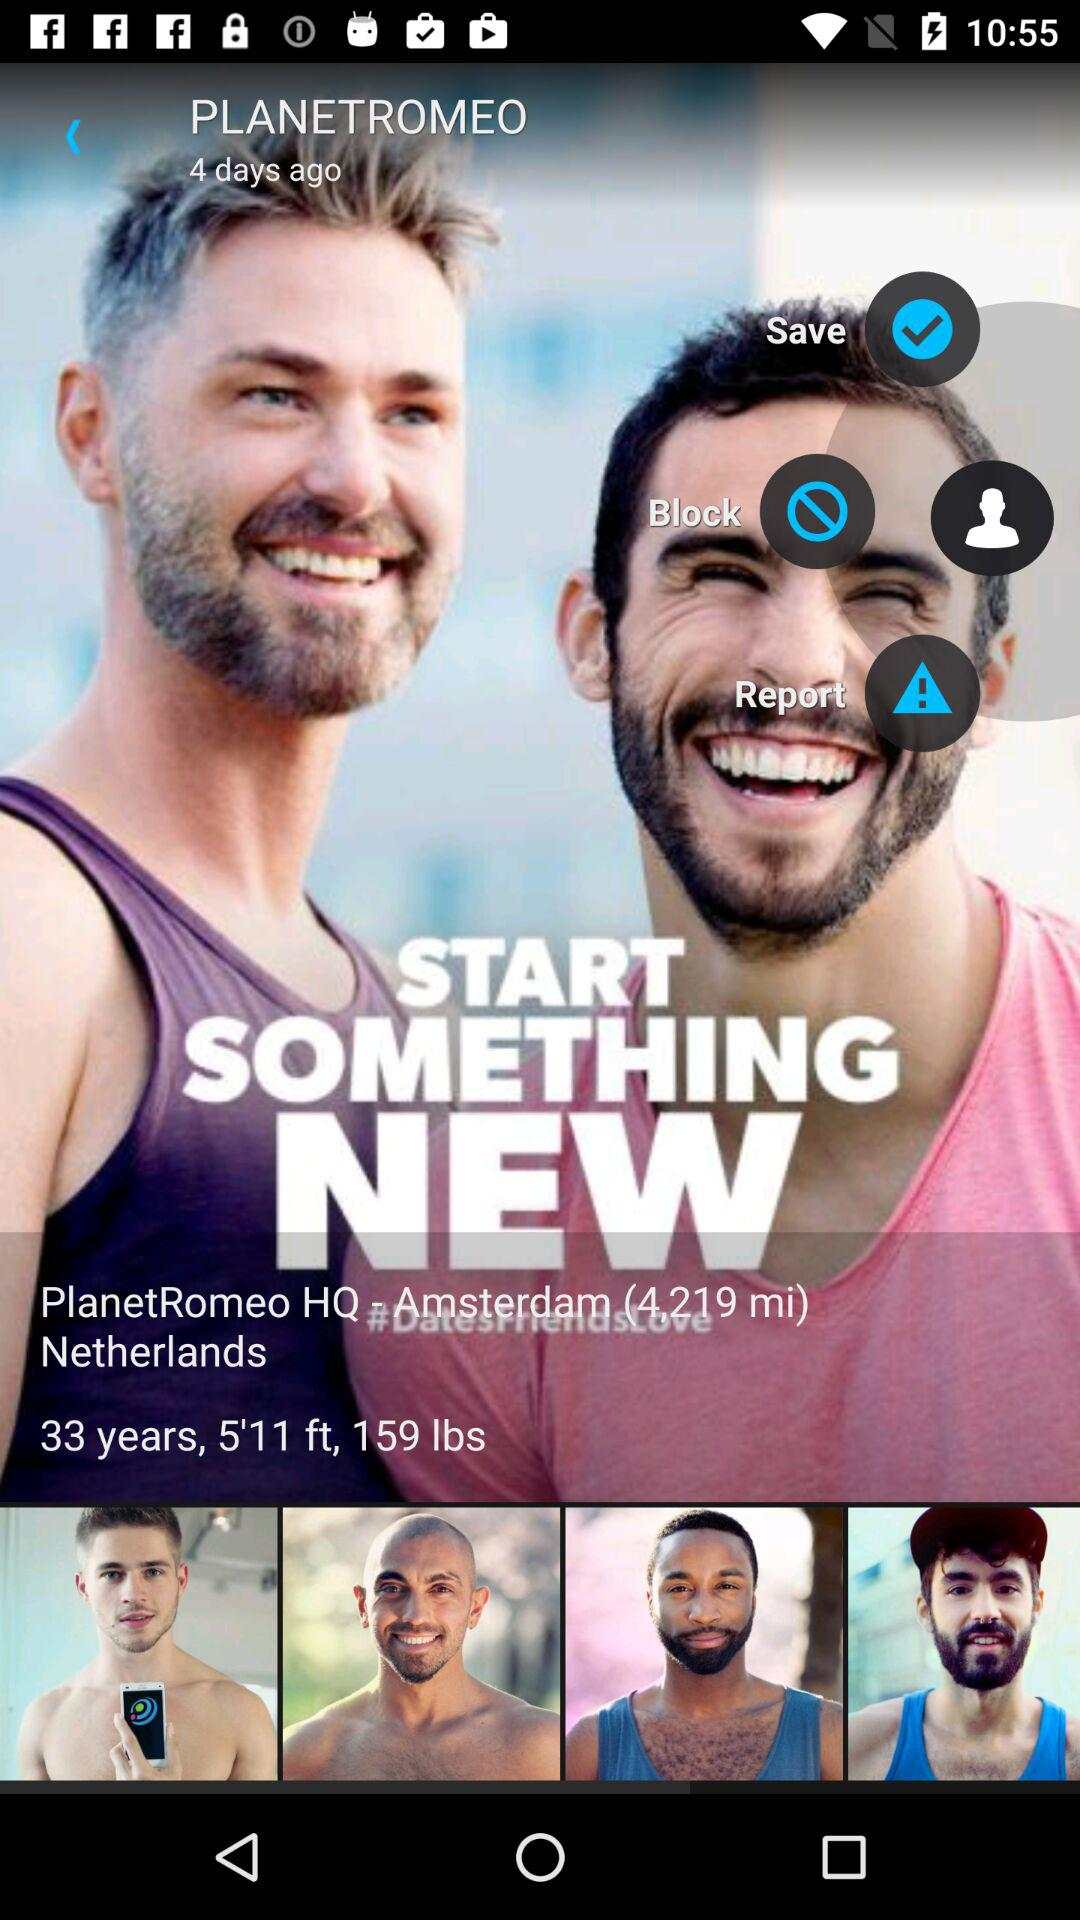What is the location? The location is PlanetRomeo HQ, Amsterdam, Netherlands. 